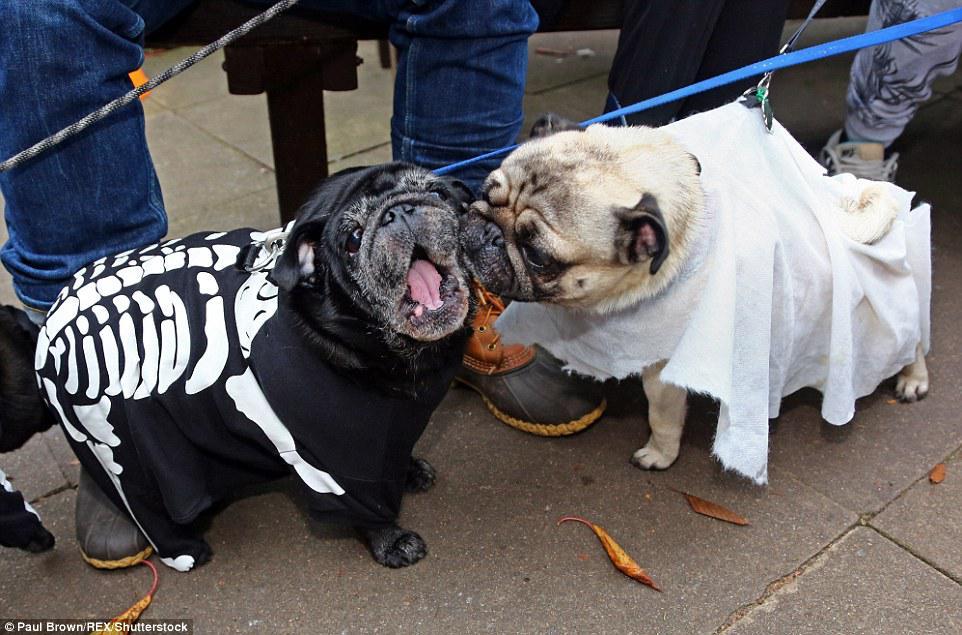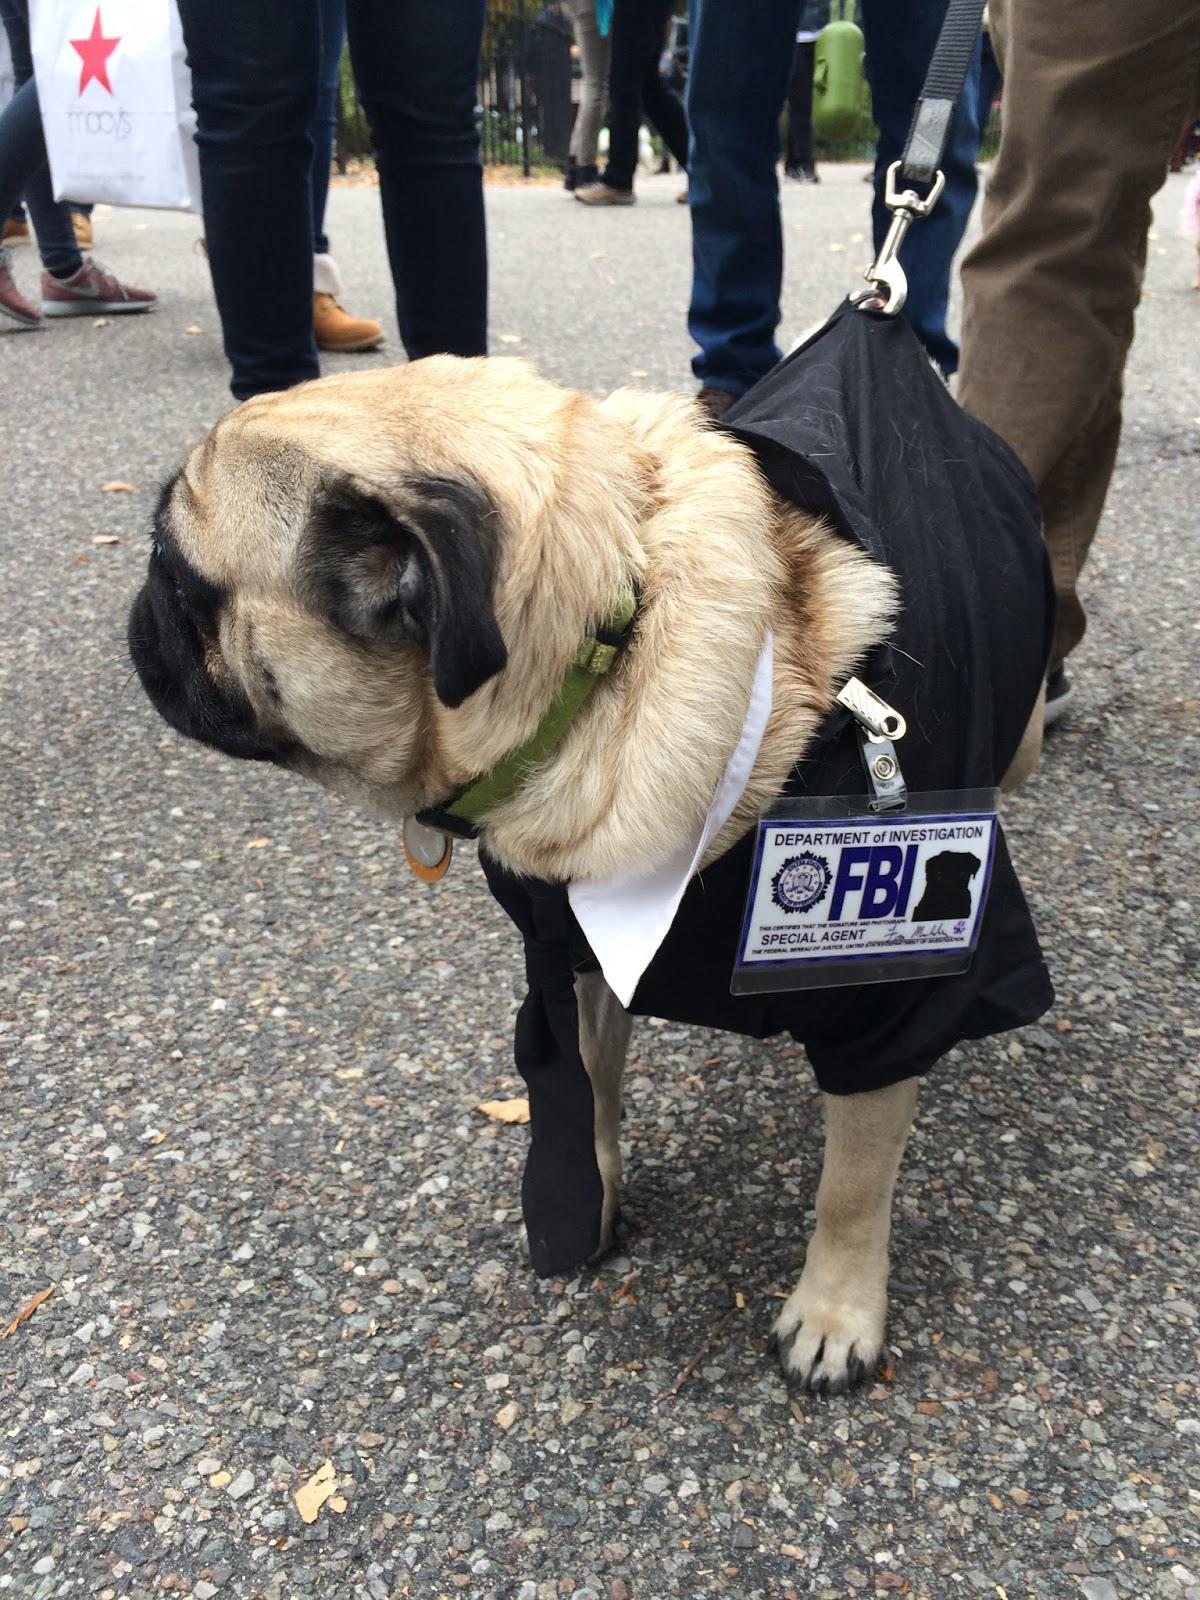The first image is the image on the left, the second image is the image on the right. For the images shown, is this caption "There is one dog touching another dog with their face in one of the images." true? Answer yes or no. Yes. The first image is the image on the left, the second image is the image on the right. Analyze the images presented: Is the assertion "One image shows a beige pug in a white 'sheet' leaning its face into a black pug wearing a skeleton costume." valid? Answer yes or no. Yes. 